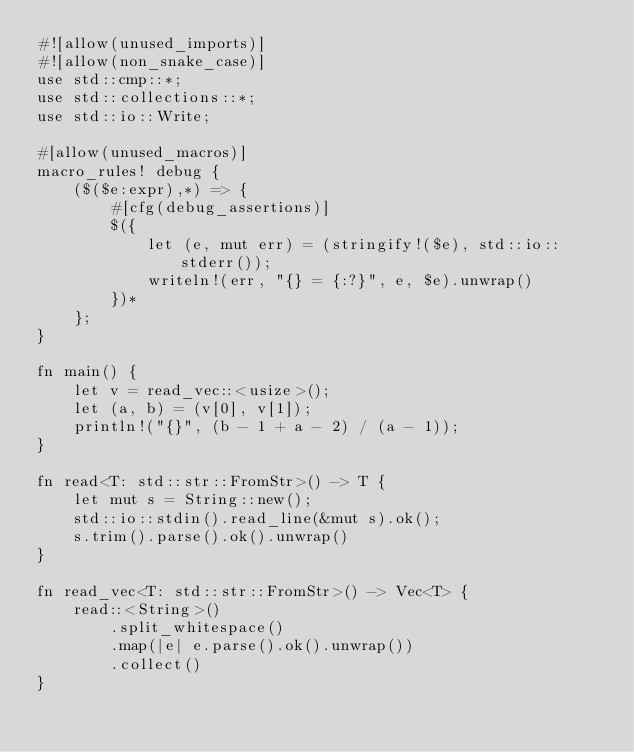<code> <loc_0><loc_0><loc_500><loc_500><_Rust_>#![allow(unused_imports)]
#![allow(non_snake_case)]
use std::cmp::*;
use std::collections::*;
use std::io::Write;

#[allow(unused_macros)]
macro_rules! debug {
    ($($e:expr),*) => {
        #[cfg(debug_assertions)]
        $({
            let (e, mut err) = (stringify!($e), std::io::stderr());
            writeln!(err, "{} = {:?}", e, $e).unwrap()
        })*
    };
}

fn main() {
    let v = read_vec::<usize>();
    let (a, b) = (v[0], v[1]);
    println!("{}", (b - 1 + a - 2) / (a - 1));
}

fn read<T: std::str::FromStr>() -> T {
    let mut s = String::new();
    std::io::stdin().read_line(&mut s).ok();
    s.trim().parse().ok().unwrap()
}

fn read_vec<T: std::str::FromStr>() -> Vec<T> {
    read::<String>()
        .split_whitespace()
        .map(|e| e.parse().ok().unwrap())
        .collect()
}
</code> 